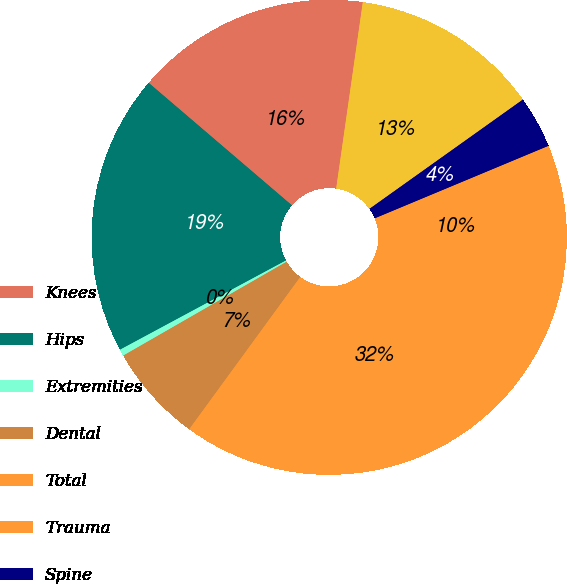<chart> <loc_0><loc_0><loc_500><loc_500><pie_chart><fcel>Knees<fcel>Hips<fcel>Extremities<fcel>Dental<fcel>Total<fcel>Trauma<fcel>Spine<fcel>OSP and other<nl><fcel>16.0%<fcel>19.11%<fcel>0.45%<fcel>6.67%<fcel>31.54%<fcel>9.78%<fcel>3.56%<fcel>12.89%<nl></chart> 